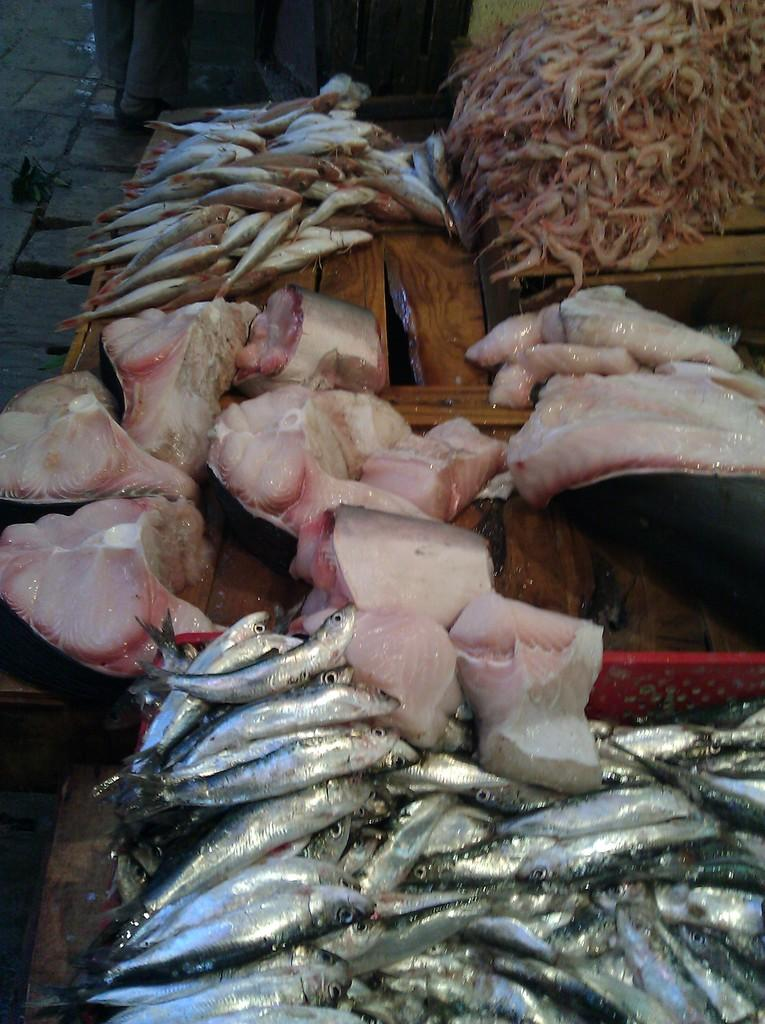What type of seafood can be seen on the table in the image? There are fishes and prawns on the table in the image. Can you describe the legs visible in the image? The legs visible in the image belong to persons. What type of tool does the carpenter use to copy the fishes in the image? There is no carpenter or tool visible in the image, and the fishes are not being copied. 